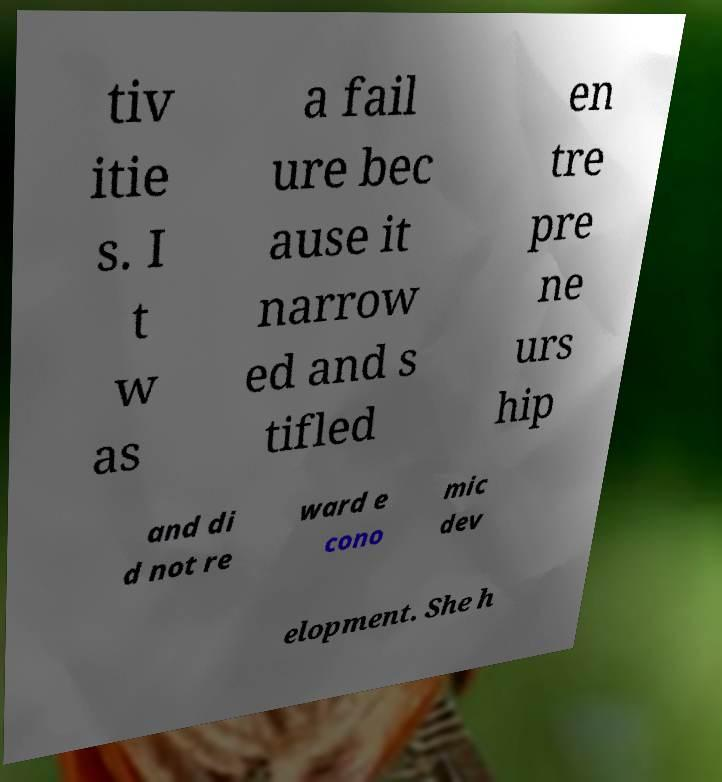There's text embedded in this image that I need extracted. Can you transcribe it verbatim? tiv itie s. I t w as a fail ure bec ause it narrow ed and s tifled en tre pre ne urs hip and di d not re ward e cono mic dev elopment. She h 